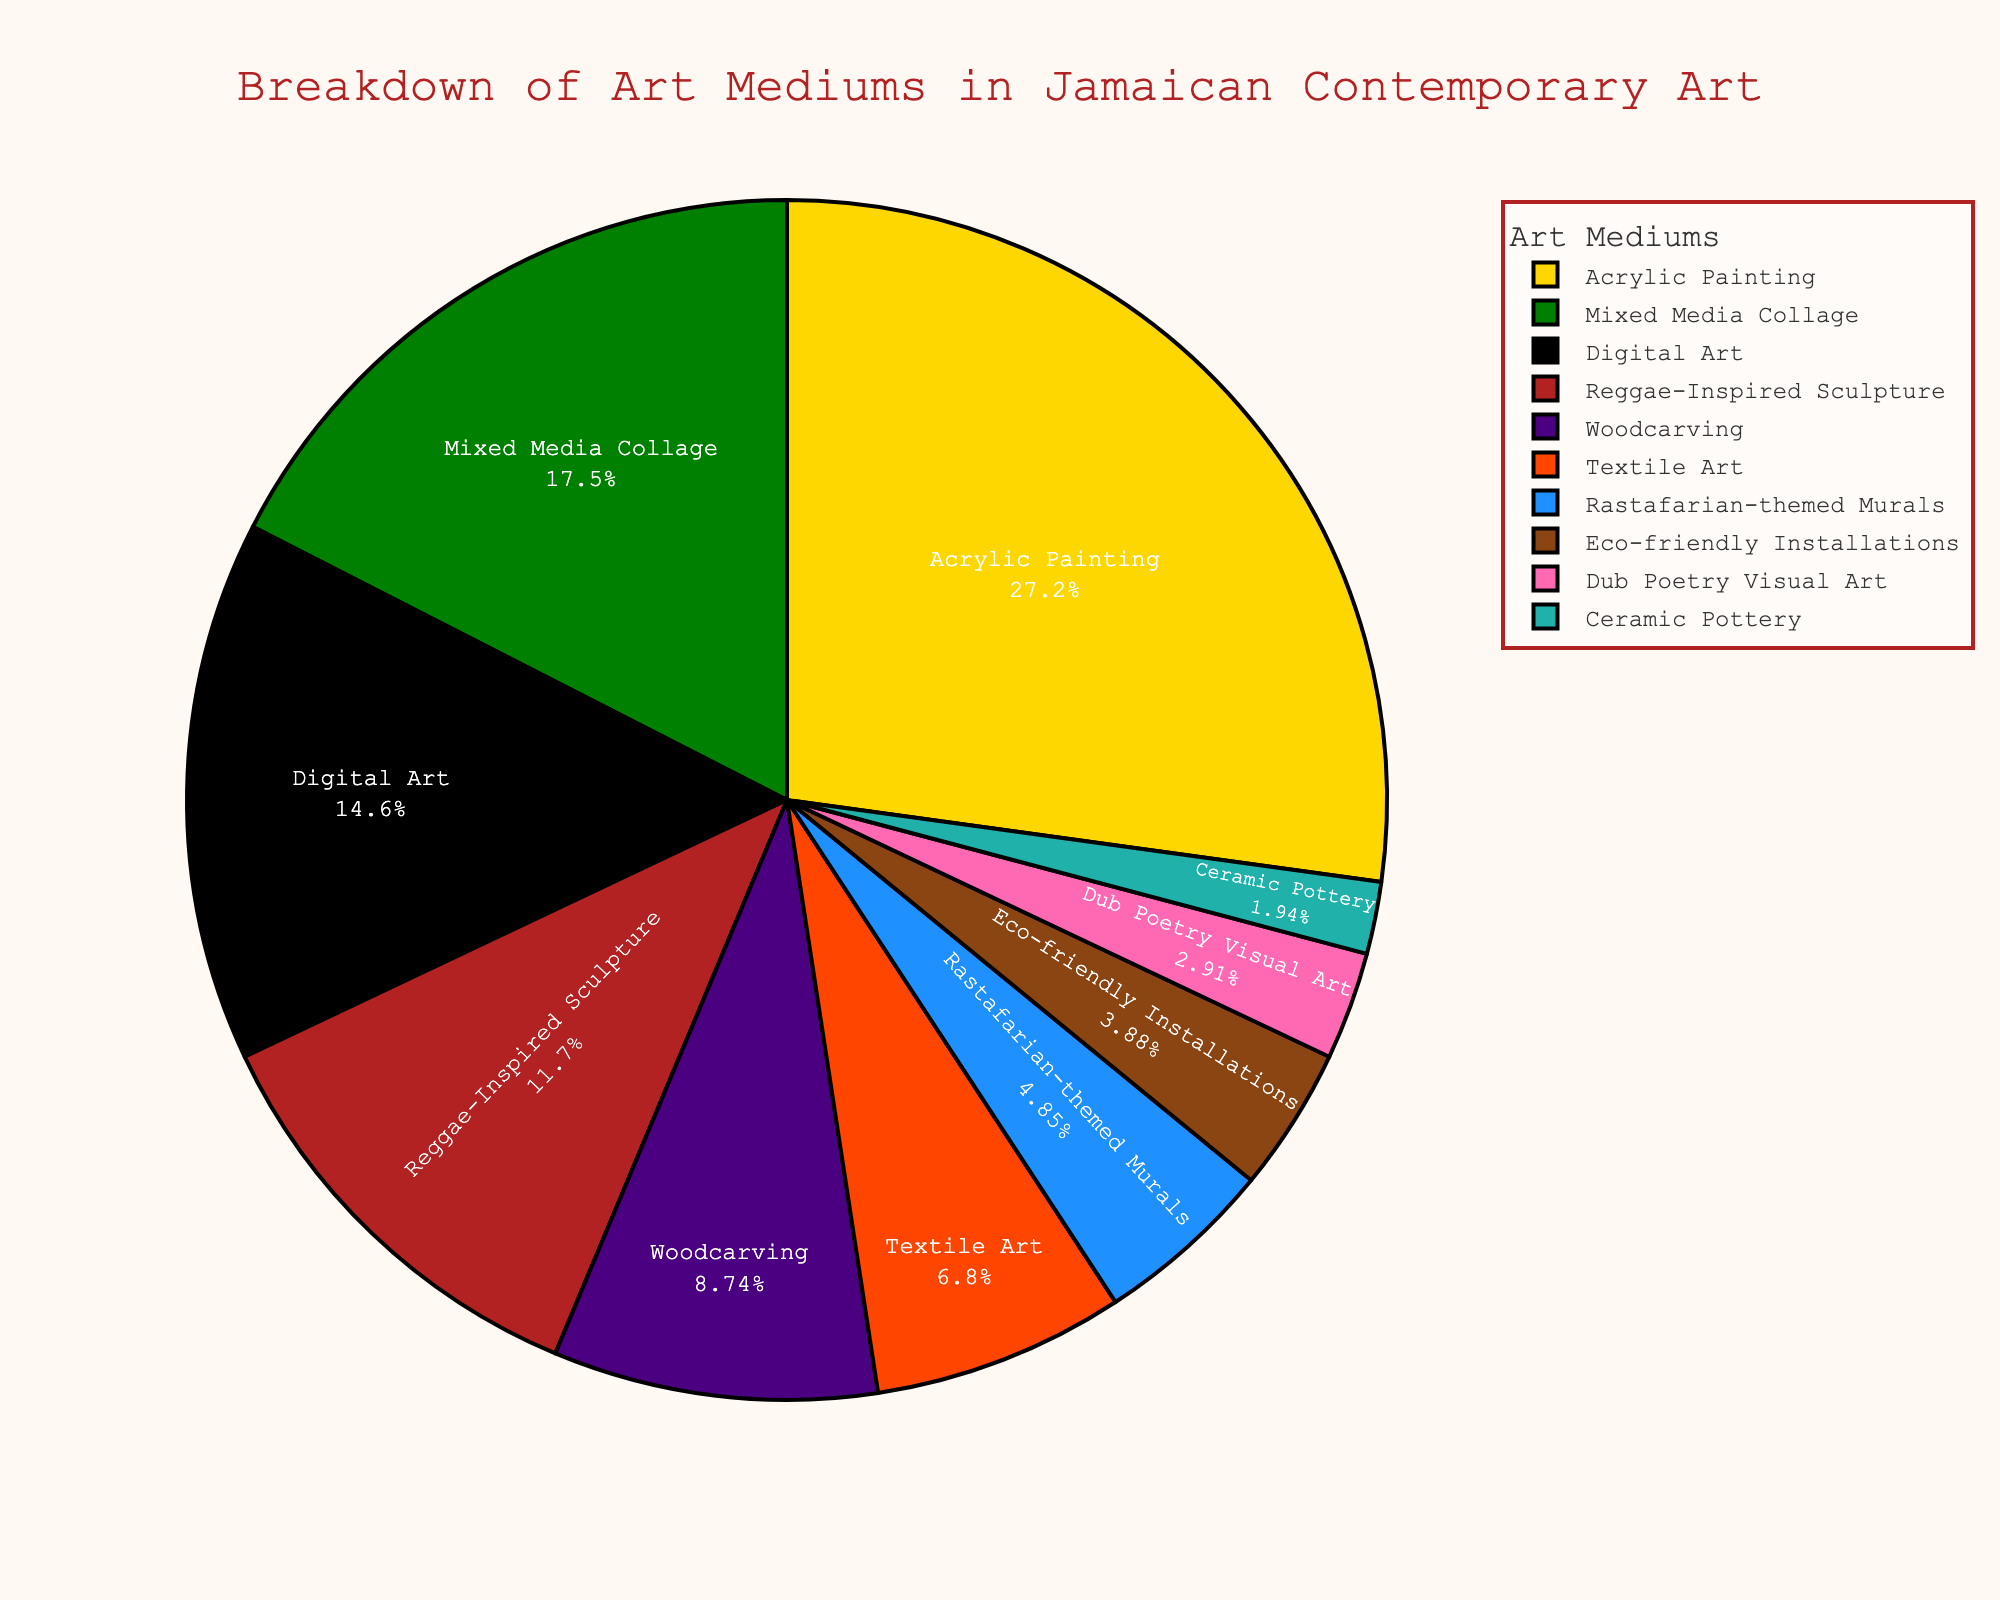Which art medium has the highest percentage in the pie chart? Looking at the breakdown of the art mediums in the pie chart, the segment with the largest percentage is easily identified as Acrylic Painting.
Answer: Acrylic Painting How does the percentage of Digital Art compare to Textile Art? Examining the pie chart, Digital Art is 15%, and Textile Art is 7%. Digital Art is therefore more prominent.
Answer: Digital Art > Textile Art What is the combined percentage of Reggae-Inspired Sculpture and Woodcarving? Adding the percentages of Reggae-Inspired Sculpture (12%) and Woodcarving (9%), the combined total is 12% + 9% = 21%.
Answer: 21% Which medium has a percentage closest to 5%? Observing the segments, Rastafarian-themed Murals have a percentage of 5%, matching the closest.
Answer: Rastafarian-themed Murals What color represents Mixed Media Collage in the chart? By matching the colors with their respective labels, Mixed Media Collage is represented by the second color, which matches a green shade.
Answer: Green Are there more art mediums over or under 10%? Counting the segments, there are six mediums under 10%: Woodcarving, Textile Art, Rastafarian-themed Murals, Eco-friendly Installations, Dub Poetry Visual Art, and Ceramic Pottery. Four mediums are over 10%. Thus, more mediums are under 10%.
Answer: Under What is the visual representation for the least used art medium? The smallest segment in the pie chart represents Ceramic Pottery with 2%. It can be seen by the smallest slice of the pie.
Answer: Ceramic Pottery What is the difference in percentage between the highest and the lowest art mediums? The highest percentage, Acrylic Painting, is 28%, and the lowest, Ceramic Pottery, is 2%. The difference is 28% - 2% = 26%.
Answer: 26% Is there more or less Eco-friendly Installations compared to Dub Poetry Visual Art? Comparing the slices in the pie chart, Eco-friendly Installations (4%) have a larger representation than Dub Poetry Visual Art (3%).
Answer: More What is the total percentage of all art mediums except the top three? Summing the percentages of mediums excluding the top three (Acrylic Painting, Mixed Media Collage, Digital Art), the remaining mediums are: 12% (Reggae-Inspired Sculpture) + 9% (Woodcarving) + 7% (Textile Art) + 5% (Rastafarian-themed Murals) + 4% (Eco-friendly Installations) + 3% (Dub Poetry Visual Art) + 2% (Ceramic Pottery), which equals 42%.
Answer: 42% 